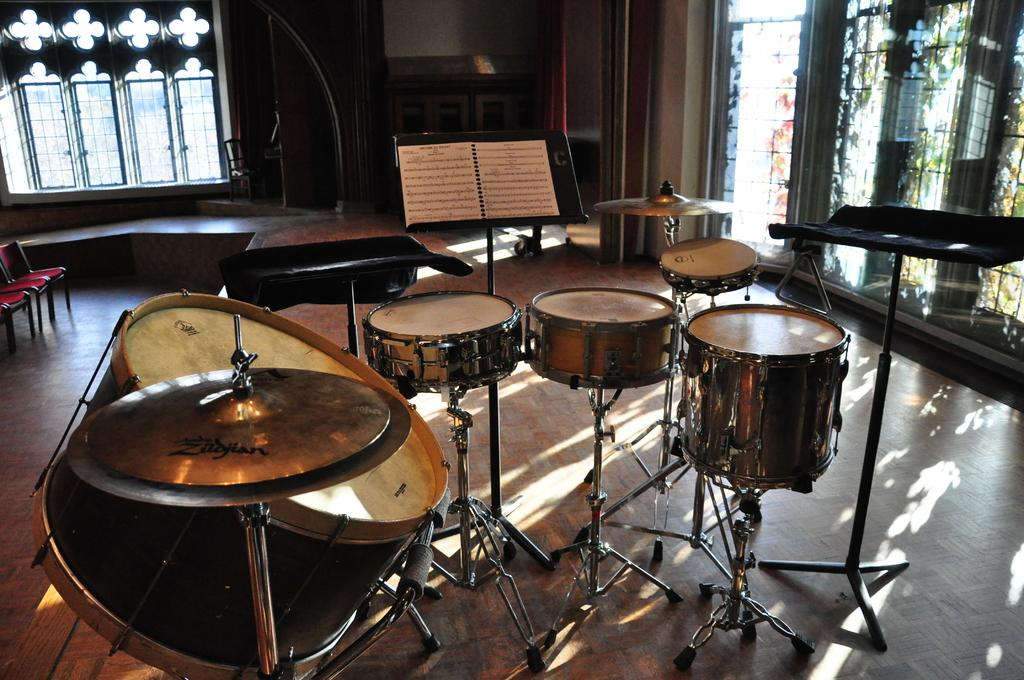What type of musical instruments are present in the image? There are drums in the image. What else can be seen in the image besides the drums? There are other musical instruments and chairs in the image. What can be seen in the background of the image? There are windows and other objects in the background of the image. What degree does the zebra have in the image? There is no zebra present in the image, so it cannot have a degree. 